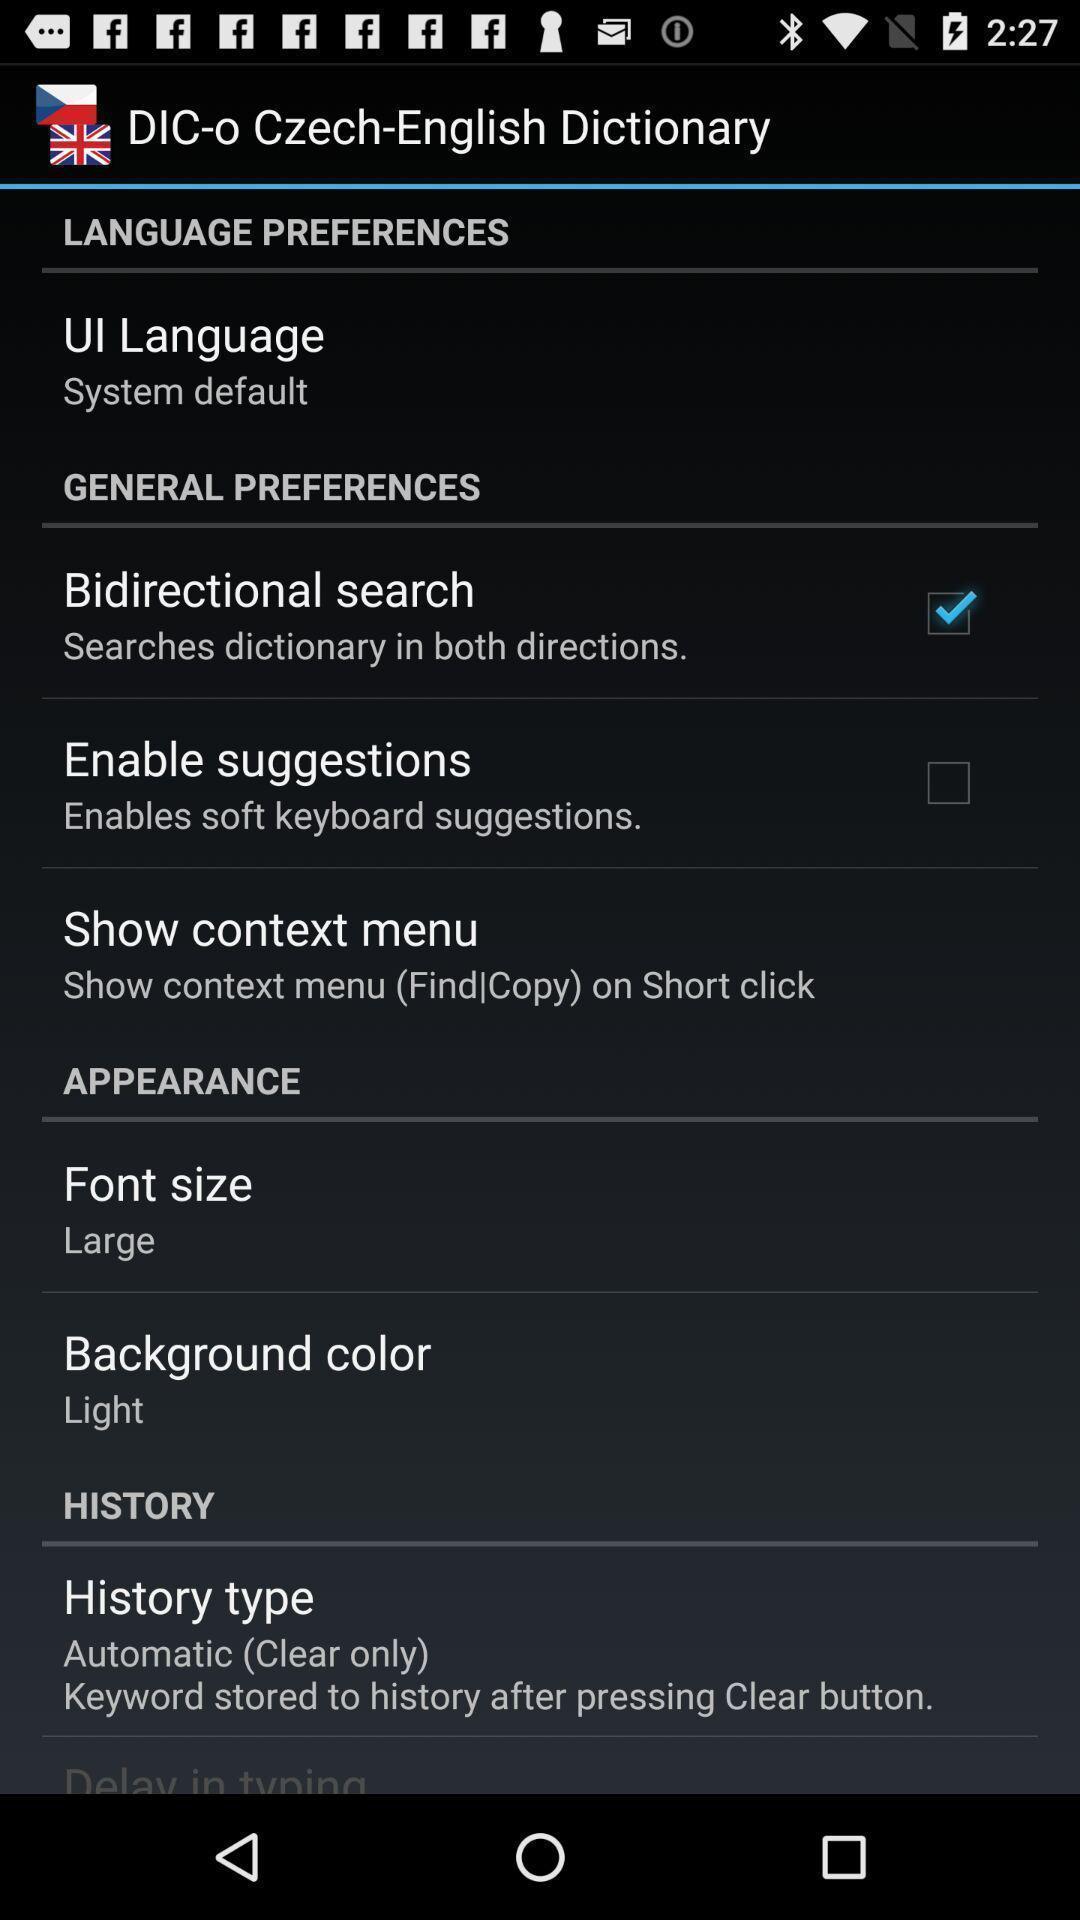What details can you identify in this image? Settings page displayed of an dictionary application. 